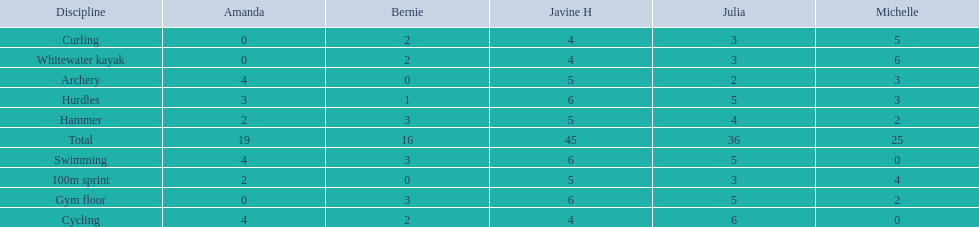Name a girl that had the same score in cycling and archery. Amanda. 